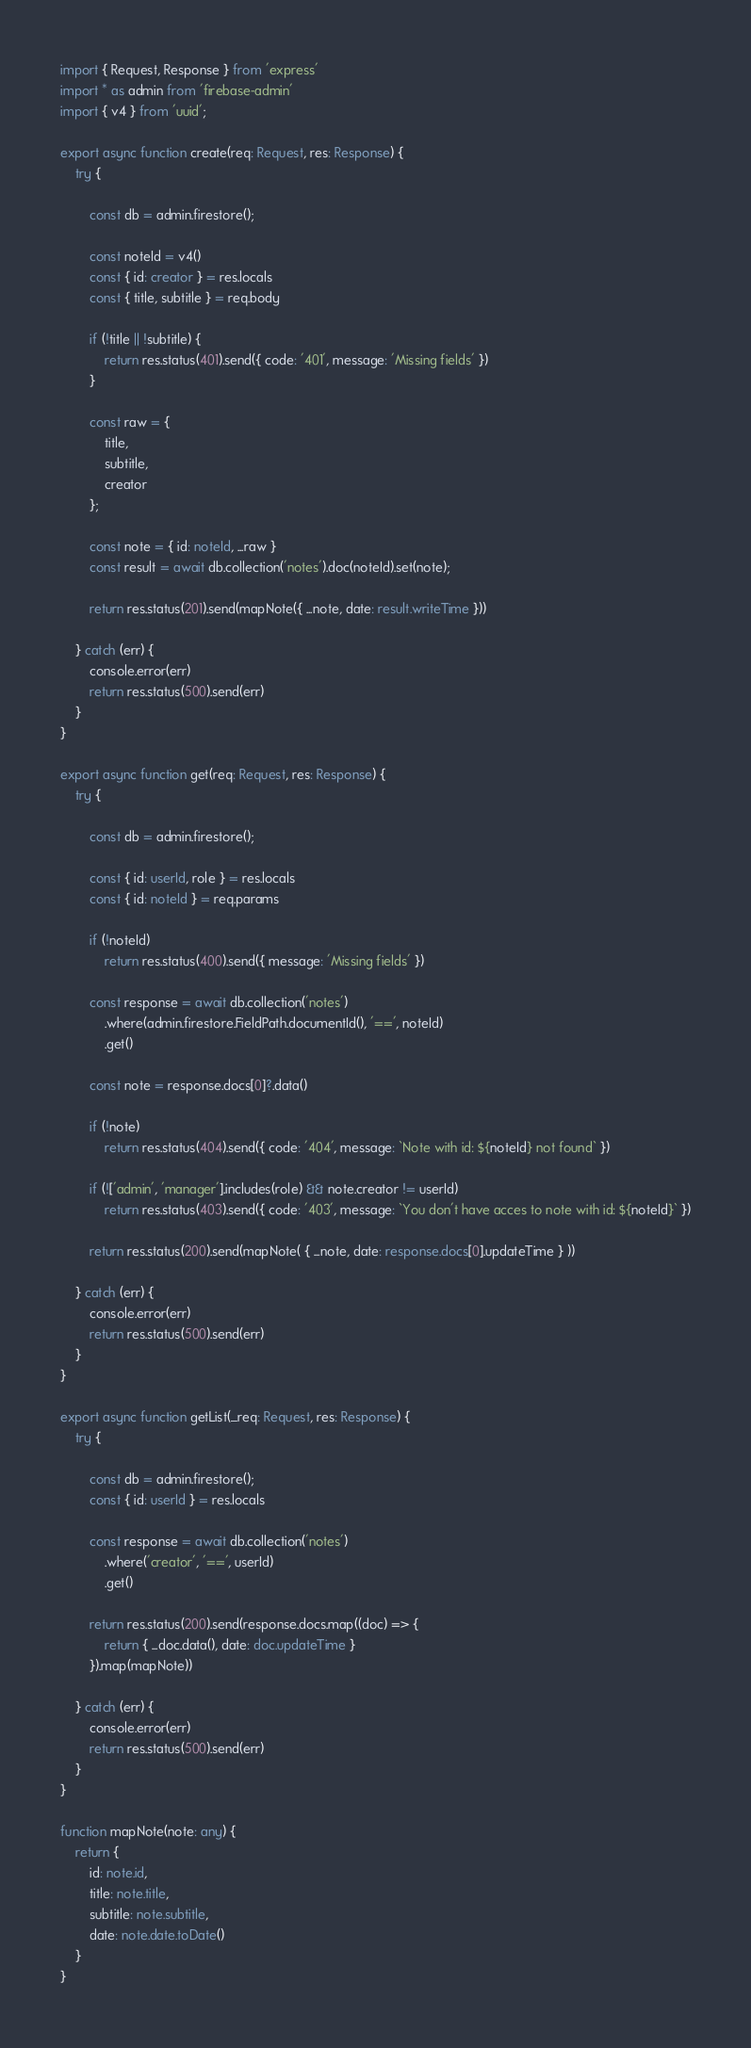Convert code to text. <code><loc_0><loc_0><loc_500><loc_500><_TypeScript_>import { Request, Response } from 'express'
import * as admin from 'firebase-admin'
import { v4 } from 'uuid';

export async function create(req: Request, res: Response) {
    try {

        const db = admin.firestore();

        const noteId = v4()
        const { id: creator } = res.locals
        const { title, subtitle } = req.body

        if (!title || !subtitle) {
            return res.status(401).send({ code: '401', message: 'Missing fields' })
        }

        const raw = {
            title,
            subtitle,
            creator
        };

        const note = { id: noteId, ...raw }
        const result = await db.collection('notes').doc(noteId).set(note);
        
        return res.status(201).send(mapNote({ ...note, date: result.writeTime }))

    } catch (err) {
        console.error(err)
        return res.status(500).send(err)
    }
}

export async function get(req: Request, res: Response) {
    try {

        const db = admin.firestore();

        const { id: userId, role } = res.locals
        const { id: noteId } = req.params

        if (!noteId)
            return res.status(400).send({ message: 'Missing fields' })

        const response = await db.collection('notes')
            .where(admin.firestore.FieldPath.documentId(), '==', noteId)
            .get()

        const note = response.docs[0]?.data()

        if (!note)
            return res.status(404).send({ code: '404', message: `Note with id: ${noteId} not found` })

        if (!['admin', 'manager'].includes(role) && note.creator != userId)
            return res.status(403).send({ code: '403', message: `You don't have acces to note with id: ${noteId}` })

        return res.status(200).send(mapNote( { ...note, date: response.docs[0].updateTime } ))

    } catch (err) {
        console.error(err)
        return res.status(500).send(err)
    }
}

export async function getList(_req: Request, res: Response) {
    try {

        const db = admin.firestore();
        const { id: userId } = res.locals

        const response = await db.collection('notes')
            .where('creator', '==', userId)
            .get()

        return res.status(200).send(response.docs.map((doc) => {
            return { ...doc.data(), date: doc.updateTime }
        }).map(mapNote))

    } catch (err) {
        console.error(err)
        return res.status(500).send(err)
    }
}

function mapNote(note: any) {
    return {
        id: note.id,
        title: note.title,
        subtitle: note.subtitle,
        date: note.date.toDate()
    }
}</code> 